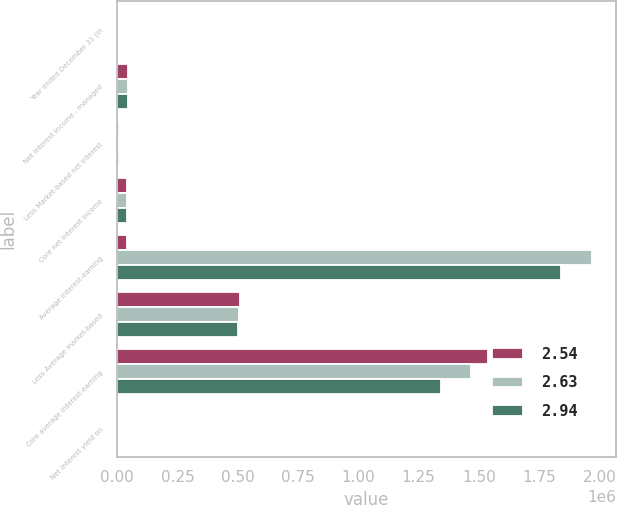<chart> <loc_0><loc_0><loc_500><loc_500><stacked_bar_chart><ecel><fcel>Year ended December 31 (in<fcel>Net interest income - managed<fcel>Less Market-based net interest<fcel>Core net interest income<fcel>Average interest-earning<fcel>Less Average market-based<fcel>Core average interest-earning<fcel>Net interest yield on<nl><fcel>2.54<fcel>2014<fcel>44619<fcel>5552<fcel>39067<fcel>39430<fcel>510261<fcel>1.53883e+06<fcel>2.18<nl><fcel>2.63<fcel>2013<fcel>44016<fcel>5492<fcel>38524<fcel>1.97023e+06<fcel>504218<fcel>1.46601e+06<fcel>2.23<nl><fcel>2.94<fcel>2012<fcel>45653<fcel>6223<fcel>39430<fcel>1.84242e+06<fcel>499339<fcel>1.34308e+06<fcel>2.48<nl></chart> 